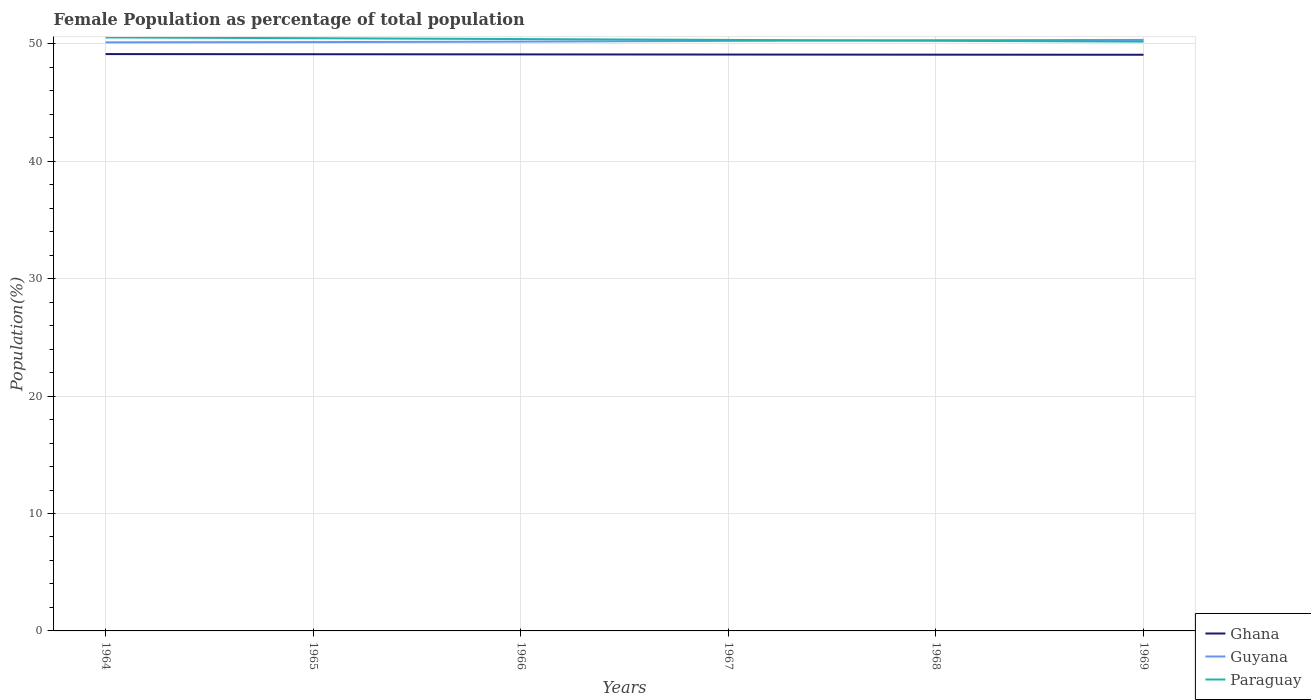Does the line corresponding to Paraguay intersect with the line corresponding to Ghana?
Your answer should be compact. No. Across all years, what is the maximum female population in in Ghana?
Make the answer very short. 49.07. In which year was the female population in in Guyana maximum?
Your answer should be compact. 1964. What is the total female population in in Guyana in the graph?
Keep it short and to the point. -0.06. What is the difference between the highest and the second highest female population in in Guyana?
Keep it short and to the point. 0.21. What is the difference between the highest and the lowest female population in in Ghana?
Offer a terse response. 3. How many lines are there?
Provide a short and direct response. 3. What is the difference between two consecutive major ticks on the Y-axis?
Offer a very short reply. 10. Does the graph contain any zero values?
Make the answer very short. No. Does the graph contain grids?
Your answer should be very brief. Yes. Where does the legend appear in the graph?
Offer a terse response. Bottom right. How are the legend labels stacked?
Keep it short and to the point. Vertical. What is the title of the graph?
Make the answer very short. Female Population as percentage of total population. What is the label or title of the Y-axis?
Ensure brevity in your answer.  Population(%). What is the Population(%) in Ghana in 1964?
Offer a terse response. 49.13. What is the Population(%) in Guyana in 1964?
Provide a short and direct response. 50.13. What is the Population(%) of Paraguay in 1964?
Make the answer very short. 50.54. What is the Population(%) in Ghana in 1965?
Offer a terse response. 49.11. What is the Population(%) of Guyana in 1965?
Your answer should be compact. 50.15. What is the Population(%) in Paraguay in 1965?
Ensure brevity in your answer.  50.48. What is the Population(%) of Ghana in 1966?
Your response must be concise. 49.1. What is the Population(%) of Guyana in 1966?
Your answer should be very brief. 50.19. What is the Population(%) of Paraguay in 1966?
Your response must be concise. 50.41. What is the Population(%) of Ghana in 1967?
Make the answer very short. 49.09. What is the Population(%) of Guyana in 1967?
Make the answer very short. 50.25. What is the Population(%) in Paraguay in 1967?
Give a very brief answer. 50.33. What is the Population(%) of Ghana in 1968?
Give a very brief answer. 49.08. What is the Population(%) in Guyana in 1968?
Provide a short and direct response. 50.31. What is the Population(%) of Paraguay in 1968?
Offer a terse response. 50.26. What is the Population(%) in Ghana in 1969?
Your response must be concise. 49.07. What is the Population(%) of Guyana in 1969?
Make the answer very short. 50.33. What is the Population(%) of Paraguay in 1969?
Offer a terse response. 50.19. Across all years, what is the maximum Population(%) in Ghana?
Make the answer very short. 49.13. Across all years, what is the maximum Population(%) of Guyana?
Provide a succinct answer. 50.33. Across all years, what is the maximum Population(%) of Paraguay?
Your response must be concise. 50.54. Across all years, what is the minimum Population(%) in Ghana?
Your response must be concise. 49.07. Across all years, what is the minimum Population(%) of Guyana?
Give a very brief answer. 50.13. Across all years, what is the minimum Population(%) of Paraguay?
Provide a short and direct response. 50.19. What is the total Population(%) in Ghana in the graph?
Offer a very short reply. 294.58. What is the total Population(%) in Guyana in the graph?
Offer a very short reply. 301.35. What is the total Population(%) in Paraguay in the graph?
Keep it short and to the point. 302.21. What is the difference between the Population(%) in Ghana in 1964 and that in 1965?
Keep it short and to the point. 0.01. What is the difference between the Population(%) of Guyana in 1964 and that in 1965?
Keep it short and to the point. -0.02. What is the difference between the Population(%) of Paraguay in 1964 and that in 1965?
Offer a terse response. 0.07. What is the difference between the Population(%) in Ghana in 1964 and that in 1966?
Keep it short and to the point. 0.03. What is the difference between the Population(%) in Guyana in 1964 and that in 1966?
Offer a terse response. -0.06. What is the difference between the Population(%) of Paraguay in 1964 and that in 1966?
Make the answer very short. 0.14. What is the difference between the Population(%) of Ghana in 1964 and that in 1967?
Your answer should be compact. 0.04. What is the difference between the Population(%) in Guyana in 1964 and that in 1967?
Provide a short and direct response. -0.12. What is the difference between the Population(%) of Paraguay in 1964 and that in 1967?
Ensure brevity in your answer.  0.21. What is the difference between the Population(%) of Ghana in 1964 and that in 1968?
Your answer should be very brief. 0.05. What is the difference between the Population(%) of Guyana in 1964 and that in 1968?
Ensure brevity in your answer.  -0.18. What is the difference between the Population(%) of Paraguay in 1964 and that in 1968?
Keep it short and to the point. 0.28. What is the difference between the Population(%) in Ghana in 1964 and that in 1969?
Offer a terse response. 0.06. What is the difference between the Population(%) in Guyana in 1964 and that in 1969?
Give a very brief answer. -0.21. What is the difference between the Population(%) of Paraguay in 1964 and that in 1969?
Provide a short and direct response. 0.36. What is the difference between the Population(%) in Ghana in 1965 and that in 1966?
Your response must be concise. 0.01. What is the difference between the Population(%) of Guyana in 1965 and that in 1966?
Offer a very short reply. -0.04. What is the difference between the Population(%) of Paraguay in 1965 and that in 1966?
Make the answer very short. 0.07. What is the difference between the Population(%) of Ghana in 1965 and that in 1967?
Your response must be concise. 0.03. What is the difference between the Population(%) of Guyana in 1965 and that in 1967?
Provide a succinct answer. -0.1. What is the difference between the Population(%) of Paraguay in 1965 and that in 1967?
Keep it short and to the point. 0.14. What is the difference between the Population(%) of Ghana in 1965 and that in 1968?
Keep it short and to the point. 0.04. What is the difference between the Population(%) of Guyana in 1965 and that in 1968?
Offer a terse response. -0.16. What is the difference between the Population(%) in Paraguay in 1965 and that in 1968?
Provide a succinct answer. 0.22. What is the difference between the Population(%) in Ghana in 1965 and that in 1969?
Your answer should be compact. 0.04. What is the difference between the Population(%) in Guyana in 1965 and that in 1969?
Keep it short and to the point. -0.19. What is the difference between the Population(%) in Paraguay in 1965 and that in 1969?
Offer a terse response. 0.29. What is the difference between the Population(%) in Ghana in 1966 and that in 1967?
Offer a very short reply. 0.01. What is the difference between the Population(%) in Guyana in 1966 and that in 1967?
Provide a short and direct response. -0.06. What is the difference between the Population(%) in Paraguay in 1966 and that in 1967?
Ensure brevity in your answer.  0.07. What is the difference between the Population(%) of Ghana in 1966 and that in 1968?
Provide a succinct answer. 0.02. What is the difference between the Population(%) of Guyana in 1966 and that in 1968?
Make the answer very short. -0.12. What is the difference between the Population(%) of Paraguay in 1966 and that in 1968?
Offer a terse response. 0.15. What is the difference between the Population(%) of Ghana in 1966 and that in 1969?
Your response must be concise. 0.03. What is the difference between the Population(%) of Guyana in 1966 and that in 1969?
Your answer should be very brief. -0.14. What is the difference between the Population(%) of Paraguay in 1966 and that in 1969?
Your response must be concise. 0.22. What is the difference between the Population(%) in Ghana in 1967 and that in 1968?
Make the answer very short. 0.01. What is the difference between the Population(%) of Guyana in 1967 and that in 1968?
Your answer should be compact. -0.06. What is the difference between the Population(%) in Paraguay in 1967 and that in 1968?
Offer a very short reply. 0.07. What is the difference between the Population(%) in Ghana in 1967 and that in 1969?
Keep it short and to the point. 0.02. What is the difference between the Population(%) of Guyana in 1967 and that in 1969?
Make the answer very short. -0.08. What is the difference between the Population(%) in Paraguay in 1967 and that in 1969?
Your answer should be very brief. 0.15. What is the difference between the Population(%) of Ghana in 1968 and that in 1969?
Offer a terse response. 0.01. What is the difference between the Population(%) in Guyana in 1968 and that in 1969?
Give a very brief answer. -0.03. What is the difference between the Population(%) in Paraguay in 1968 and that in 1969?
Your answer should be very brief. 0.07. What is the difference between the Population(%) of Ghana in 1964 and the Population(%) of Guyana in 1965?
Your response must be concise. -1.02. What is the difference between the Population(%) in Ghana in 1964 and the Population(%) in Paraguay in 1965?
Your answer should be compact. -1.35. What is the difference between the Population(%) of Guyana in 1964 and the Population(%) of Paraguay in 1965?
Offer a very short reply. -0.35. What is the difference between the Population(%) in Ghana in 1964 and the Population(%) in Guyana in 1966?
Provide a short and direct response. -1.06. What is the difference between the Population(%) of Ghana in 1964 and the Population(%) of Paraguay in 1966?
Offer a very short reply. -1.28. What is the difference between the Population(%) in Guyana in 1964 and the Population(%) in Paraguay in 1966?
Give a very brief answer. -0.28. What is the difference between the Population(%) in Ghana in 1964 and the Population(%) in Guyana in 1967?
Your answer should be compact. -1.12. What is the difference between the Population(%) in Ghana in 1964 and the Population(%) in Paraguay in 1967?
Your answer should be compact. -1.21. What is the difference between the Population(%) in Guyana in 1964 and the Population(%) in Paraguay in 1967?
Provide a succinct answer. -0.21. What is the difference between the Population(%) in Ghana in 1964 and the Population(%) in Guyana in 1968?
Your response must be concise. -1.18. What is the difference between the Population(%) of Ghana in 1964 and the Population(%) of Paraguay in 1968?
Ensure brevity in your answer.  -1.13. What is the difference between the Population(%) of Guyana in 1964 and the Population(%) of Paraguay in 1968?
Keep it short and to the point. -0.13. What is the difference between the Population(%) of Ghana in 1964 and the Population(%) of Guyana in 1969?
Your response must be concise. -1.21. What is the difference between the Population(%) in Ghana in 1964 and the Population(%) in Paraguay in 1969?
Provide a short and direct response. -1.06. What is the difference between the Population(%) in Guyana in 1964 and the Population(%) in Paraguay in 1969?
Provide a short and direct response. -0.06. What is the difference between the Population(%) in Ghana in 1965 and the Population(%) in Guyana in 1966?
Provide a short and direct response. -1.07. What is the difference between the Population(%) in Ghana in 1965 and the Population(%) in Paraguay in 1966?
Keep it short and to the point. -1.29. What is the difference between the Population(%) of Guyana in 1965 and the Population(%) of Paraguay in 1966?
Keep it short and to the point. -0.26. What is the difference between the Population(%) in Ghana in 1965 and the Population(%) in Guyana in 1967?
Your answer should be very brief. -1.13. What is the difference between the Population(%) in Ghana in 1965 and the Population(%) in Paraguay in 1967?
Your answer should be compact. -1.22. What is the difference between the Population(%) of Guyana in 1965 and the Population(%) of Paraguay in 1967?
Provide a succinct answer. -0.19. What is the difference between the Population(%) in Ghana in 1965 and the Population(%) in Guyana in 1968?
Ensure brevity in your answer.  -1.19. What is the difference between the Population(%) of Ghana in 1965 and the Population(%) of Paraguay in 1968?
Give a very brief answer. -1.15. What is the difference between the Population(%) of Guyana in 1965 and the Population(%) of Paraguay in 1968?
Ensure brevity in your answer.  -0.11. What is the difference between the Population(%) in Ghana in 1965 and the Population(%) in Guyana in 1969?
Make the answer very short. -1.22. What is the difference between the Population(%) in Ghana in 1965 and the Population(%) in Paraguay in 1969?
Ensure brevity in your answer.  -1.07. What is the difference between the Population(%) in Guyana in 1965 and the Population(%) in Paraguay in 1969?
Offer a very short reply. -0.04. What is the difference between the Population(%) of Ghana in 1966 and the Population(%) of Guyana in 1967?
Make the answer very short. -1.15. What is the difference between the Population(%) of Ghana in 1966 and the Population(%) of Paraguay in 1967?
Give a very brief answer. -1.23. What is the difference between the Population(%) of Guyana in 1966 and the Population(%) of Paraguay in 1967?
Your answer should be compact. -0.14. What is the difference between the Population(%) of Ghana in 1966 and the Population(%) of Guyana in 1968?
Offer a very short reply. -1.21. What is the difference between the Population(%) in Ghana in 1966 and the Population(%) in Paraguay in 1968?
Ensure brevity in your answer.  -1.16. What is the difference between the Population(%) of Guyana in 1966 and the Population(%) of Paraguay in 1968?
Ensure brevity in your answer.  -0.07. What is the difference between the Population(%) in Ghana in 1966 and the Population(%) in Guyana in 1969?
Your answer should be very brief. -1.23. What is the difference between the Population(%) of Ghana in 1966 and the Population(%) of Paraguay in 1969?
Your response must be concise. -1.09. What is the difference between the Population(%) of Guyana in 1966 and the Population(%) of Paraguay in 1969?
Ensure brevity in your answer.  0. What is the difference between the Population(%) of Ghana in 1967 and the Population(%) of Guyana in 1968?
Your response must be concise. -1.22. What is the difference between the Population(%) in Ghana in 1967 and the Population(%) in Paraguay in 1968?
Your response must be concise. -1.17. What is the difference between the Population(%) of Guyana in 1967 and the Population(%) of Paraguay in 1968?
Offer a terse response. -0.01. What is the difference between the Population(%) of Ghana in 1967 and the Population(%) of Guyana in 1969?
Offer a terse response. -1.25. What is the difference between the Population(%) in Ghana in 1967 and the Population(%) in Paraguay in 1969?
Your response must be concise. -1.1. What is the difference between the Population(%) in Guyana in 1967 and the Population(%) in Paraguay in 1969?
Provide a succinct answer. 0.06. What is the difference between the Population(%) in Ghana in 1968 and the Population(%) in Guyana in 1969?
Your answer should be compact. -1.26. What is the difference between the Population(%) in Ghana in 1968 and the Population(%) in Paraguay in 1969?
Your answer should be very brief. -1.11. What is the difference between the Population(%) of Guyana in 1968 and the Population(%) of Paraguay in 1969?
Your answer should be compact. 0.12. What is the average Population(%) of Ghana per year?
Your answer should be very brief. 49.1. What is the average Population(%) of Guyana per year?
Provide a short and direct response. 50.23. What is the average Population(%) in Paraguay per year?
Offer a very short reply. 50.37. In the year 1964, what is the difference between the Population(%) of Ghana and Population(%) of Guyana?
Provide a succinct answer. -1. In the year 1964, what is the difference between the Population(%) of Ghana and Population(%) of Paraguay?
Make the answer very short. -1.42. In the year 1964, what is the difference between the Population(%) in Guyana and Population(%) in Paraguay?
Keep it short and to the point. -0.42. In the year 1965, what is the difference between the Population(%) in Ghana and Population(%) in Guyana?
Make the answer very short. -1.03. In the year 1965, what is the difference between the Population(%) of Ghana and Population(%) of Paraguay?
Provide a short and direct response. -1.36. In the year 1965, what is the difference between the Population(%) in Guyana and Population(%) in Paraguay?
Ensure brevity in your answer.  -0.33. In the year 1966, what is the difference between the Population(%) of Ghana and Population(%) of Guyana?
Your answer should be very brief. -1.09. In the year 1966, what is the difference between the Population(%) of Ghana and Population(%) of Paraguay?
Your answer should be compact. -1.31. In the year 1966, what is the difference between the Population(%) of Guyana and Population(%) of Paraguay?
Keep it short and to the point. -0.22. In the year 1967, what is the difference between the Population(%) in Ghana and Population(%) in Guyana?
Provide a short and direct response. -1.16. In the year 1967, what is the difference between the Population(%) of Ghana and Population(%) of Paraguay?
Offer a very short reply. -1.25. In the year 1967, what is the difference between the Population(%) in Guyana and Population(%) in Paraguay?
Ensure brevity in your answer.  -0.08. In the year 1968, what is the difference between the Population(%) in Ghana and Population(%) in Guyana?
Make the answer very short. -1.23. In the year 1968, what is the difference between the Population(%) in Ghana and Population(%) in Paraguay?
Your answer should be compact. -1.18. In the year 1968, what is the difference between the Population(%) of Guyana and Population(%) of Paraguay?
Keep it short and to the point. 0.05. In the year 1969, what is the difference between the Population(%) of Ghana and Population(%) of Guyana?
Your answer should be very brief. -1.26. In the year 1969, what is the difference between the Population(%) in Ghana and Population(%) in Paraguay?
Your answer should be very brief. -1.12. In the year 1969, what is the difference between the Population(%) of Guyana and Population(%) of Paraguay?
Make the answer very short. 0.15. What is the ratio of the Population(%) of Ghana in 1964 to that in 1966?
Keep it short and to the point. 1. What is the ratio of the Population(%) of Paraguay in 1964 to that in 1966?
Offer a terse response. 1. What is the ratio of the Population(%) in Ghana in 1964 to that in 1967?
Provide a succinct answer. 1. What is the ratio of the Population(%) of Guyana in 1964 to that in 1967?
Give a very brief answer. 1. What is the ratio of the Population(%) of Paraguay in 1964 to that in 1969?
Provide a succinct answer. 1.01. What is the ratio of the Population(%) in Guyana in 1965 to that in 1966?
Your response must be concise. 1. What is the ratio of the Population(%) in Ghana in 1965 to that in 1967?
Provide a succinct answer. 1. What is the ratio of the Population(%) in Guyana in 1965 to that in 1967?
Your answer should be very brief. 1. What is the ratio of the Population(%) in Paraguay in 1965 to that in 1967?
Your response must be concise. 1. What is the ratio of the Population(%) of Guyana in 1965 to that in 1968?
Ensure brevity in your answer.  1. What is the ratio of the Population(%) in Paraguay in 1965 to that in 1969?
Your response must be concise. 1.01. What is the ratio of the Population(%) in Guyana in 1966 to that in 1968?
Provide a succinct answer. 1. What is the ratio of the Population(%) of Guyana in 1966 to that in 1969?
Your answer should be very brief. 1. What is the ratio of the Population(%) in Paraguay in 1966 to that in 1969?
Provide a succinct answer. 1. What is the ratio of the Population(%) in Ghana in 1967 to that in 1968?
Keep it short and to the point. 1. What is the ratio of the Population(%) in Paraguay in 1967 to that in 1968?
Your answer should be compact. 1. What is the ratio of the Population(%) of Ghana in 1967 to that in 1969?
Offer a very short reply. 1. What is the ratio of the Population(%) in Paraguay in 1967 to that in 1969?
Your answer should be compact. 1. What is the ratio of the Population(%) of Paraguay in 1968 to that in 1969?
Your response must be concise. 1. What is the difference between the highest and the second highest Population(%) of Ghana?
Make the answer very short. 0.01. What is the difference between the highest and the second highest Population(%) in Guyana?
Make the answer very short. 0.03. What is the difference between the highest and the second highest Population(%) in Paraguay?
Make the answer very short. 0.07. What is the difference between the highest and the lowest Population(%) in Ghana?
Your answer should be very brief. 0.06. What is the difference between the highest and the lowest Population(%) of Guyana?
Ensure brevity in your answer.  0.21. What is the difference between the highest and the lowest Population(%) of Paraguay?
Your answer should be compact. 0.36. 